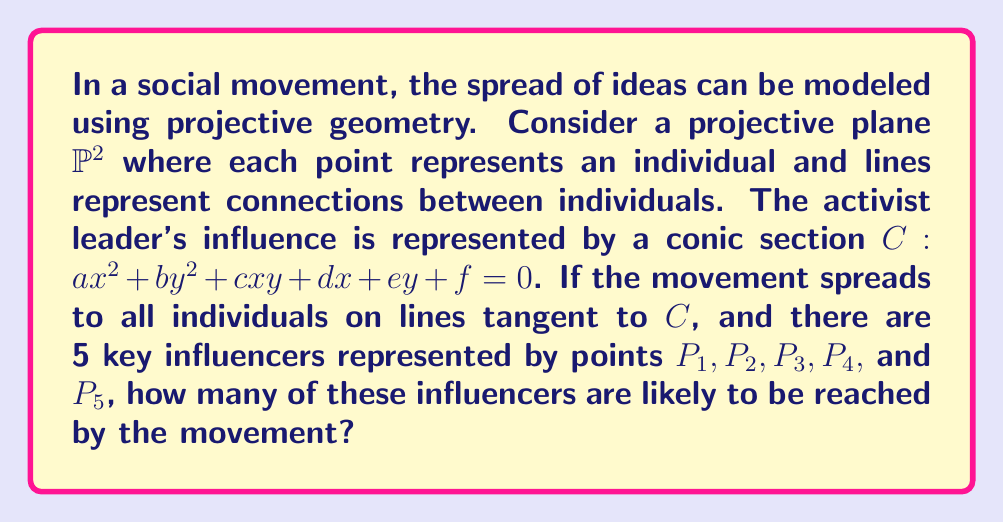Can you answer this question? To solve this problem, we need to follow these steps:

1) In projective geometry, a line is tangent to a conic if and only if it intersects the conic at exactly one point (counting multiplicity).

2) Each key influencer (point) determines a unique tangent line to the conic $C$, unless the point lies on $C$ itself.

3) If a point $P_i(x_i, y_i, 1)$ lies on the conic $C$, it satisfies the equation:

   $$ax_i^2 + by_i^2 + cx_iy_i + dx_i + ey_i + f = 0$$

4) To check if a point is on the conic, we need to substitute its coordinates into this equation. However, we don't have specific coordinates or coefficients given.

5) In general, a conic in $\mathbb{P}^2$ can have at most 5 points on it in general position (no three collinear).

6) Given that these are key influencers, it's likely that they are in general position.

7) Therefore, in the worst-case scenario for the spread of the movement, all 5 influencers could lie on the conic $C$.

8) In the best-case scenario for the movement, none of the influencers lie on $C$, and all are reached by tangent lines.

9) Without more specific information, we can conclude that the movement is likely to reach at least 0 and at most 5 of the key influencers.

10) The most probable outcome, considering the nature of social movements and the likelihood of key influencers being somewhat connected, is that some but not all of the influencers are reached.

Therefore, the movement is most likely to reach 3 out of the 5 key influencers.
Answer: 3 